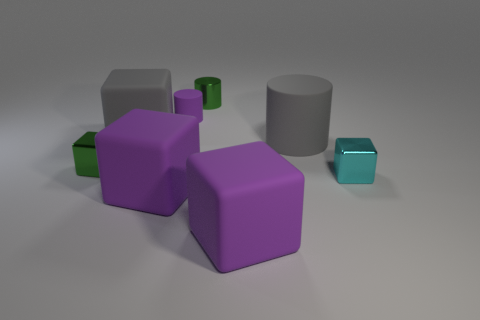Are there more green metal things that are in front of the large gray cube than big objects that are right of the tiny cyan shiny object?
Keep it short and to the point. Yes. There is a gray thing that is made of the same material as the big cylinder; what is its size?
Ensure brevity in your answer.  Large. What size is the matte thing that is behind the rubber cube behind the block that is on the right side of the large gray matte cylinder?
Keep it short and to the point. Small. What color is the cylinder that is in front of the purple matte cylinder?
Ensure brevity in your answer.  Gray. Is the number of rubber cubes behind the small cyan shiny object greater than the number of blue metal blocks?
Your answer should be compact. Yes. Do the small shiny thing that is behind the tiny green block and the tiny purple matte object have the same shape?
Your response must be concise. Yes. How many blue things are either matte things or large things?
Make the answer very short. 0. Are there more large cyan metal blocks than tiny metal cylinders?
Your response must be concise. No. There is another cylinder that is the same size as the purple matte cylinder; what is its color?
Offer a very short reply. Green. What number of spheres are either tiny cyan shiny objects or small purple things?
Provide a succinct answer. 0. 